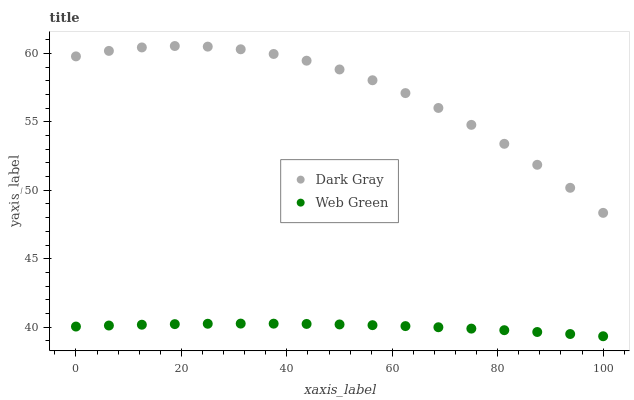Does Web Green have the minimum area under the curve?
Answer yes or no. Yes. Does Dark Gray have the maximum area under the curve?
Answer yes or no. Yes. Does Web Green have the maximum area under the curve?
Answer yes or no. No. Is Web Green the smoothest?
Answer yes or no. Yes. Is Dark Gray the roughest?
Answer yes or no. Yes. Is Web Green the roughest?
Answer yes or no. No. Does Web Green have the lowest value?
Answer yes or no. Yes. Does Dark Gray have the highest value?
Answer yes or no. Yes. Does Web Green have the highest value?
Answer yes or no. No. Is Web Green less than Dark Gray?
Answer yes or no. Yes. Is Dark Gray greater than Web Green?
Answer yes or no. Yes. Does Web Green intersect Dark Gray?
Answer yes or no. No. 